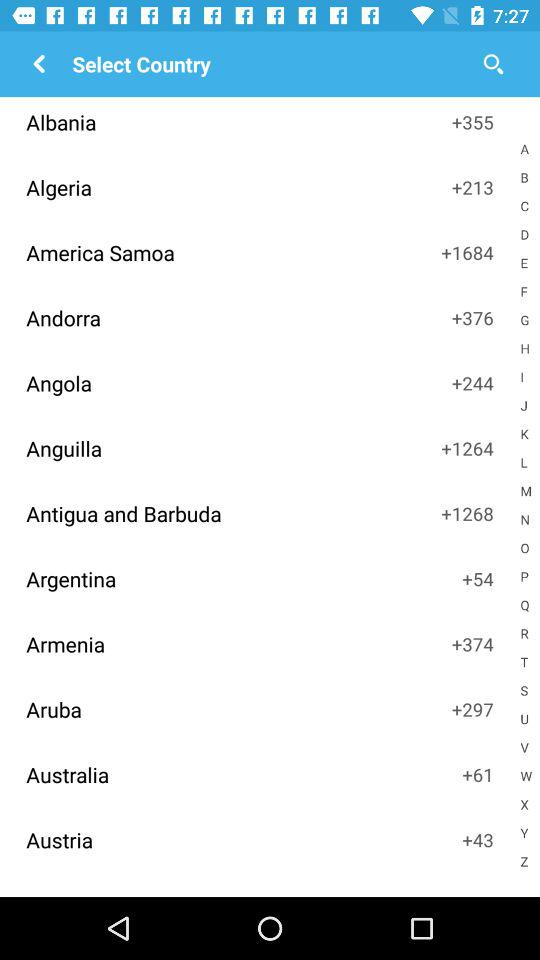What is the code of Algeria country? The code is +213. 